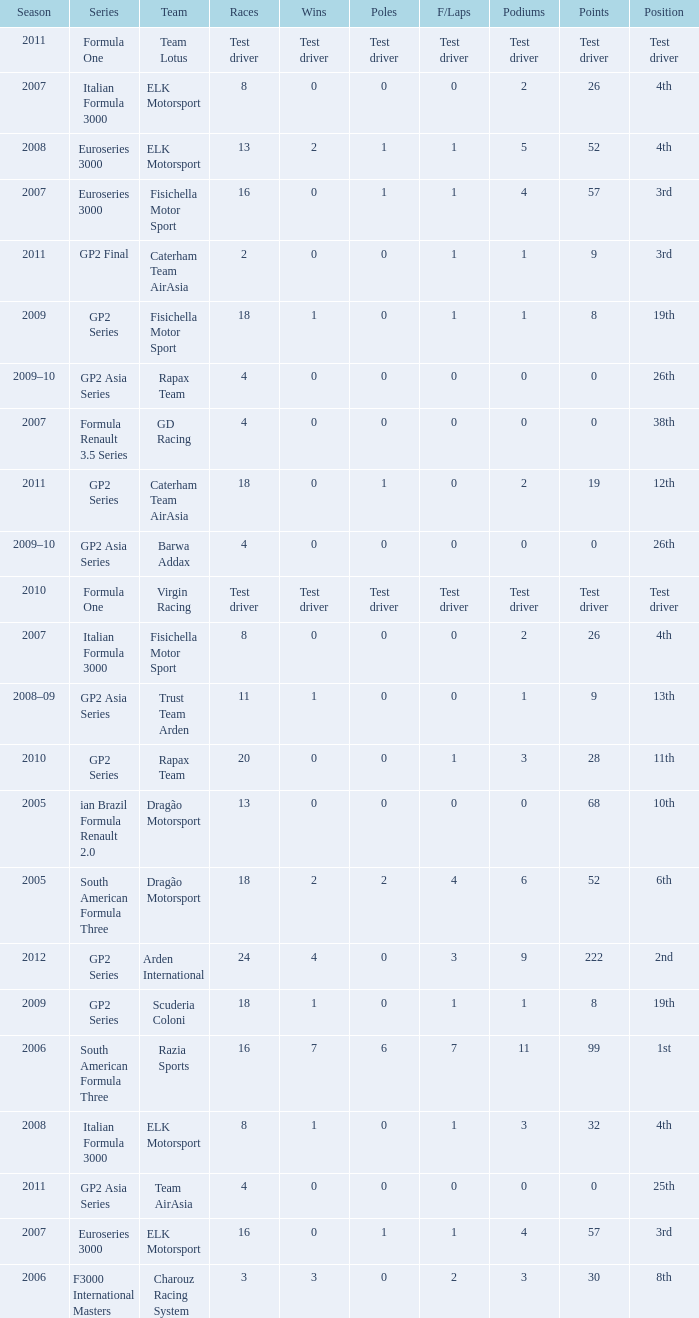In which season did he have 0 Poles and 19th position in the GP2 Series? 2009, 2009. 